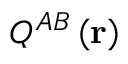Convert formula to latex. <formula><loc_0><loc_0><loc_500><loc_500>Q ^ { A B } \left ( r \right )</formula> 